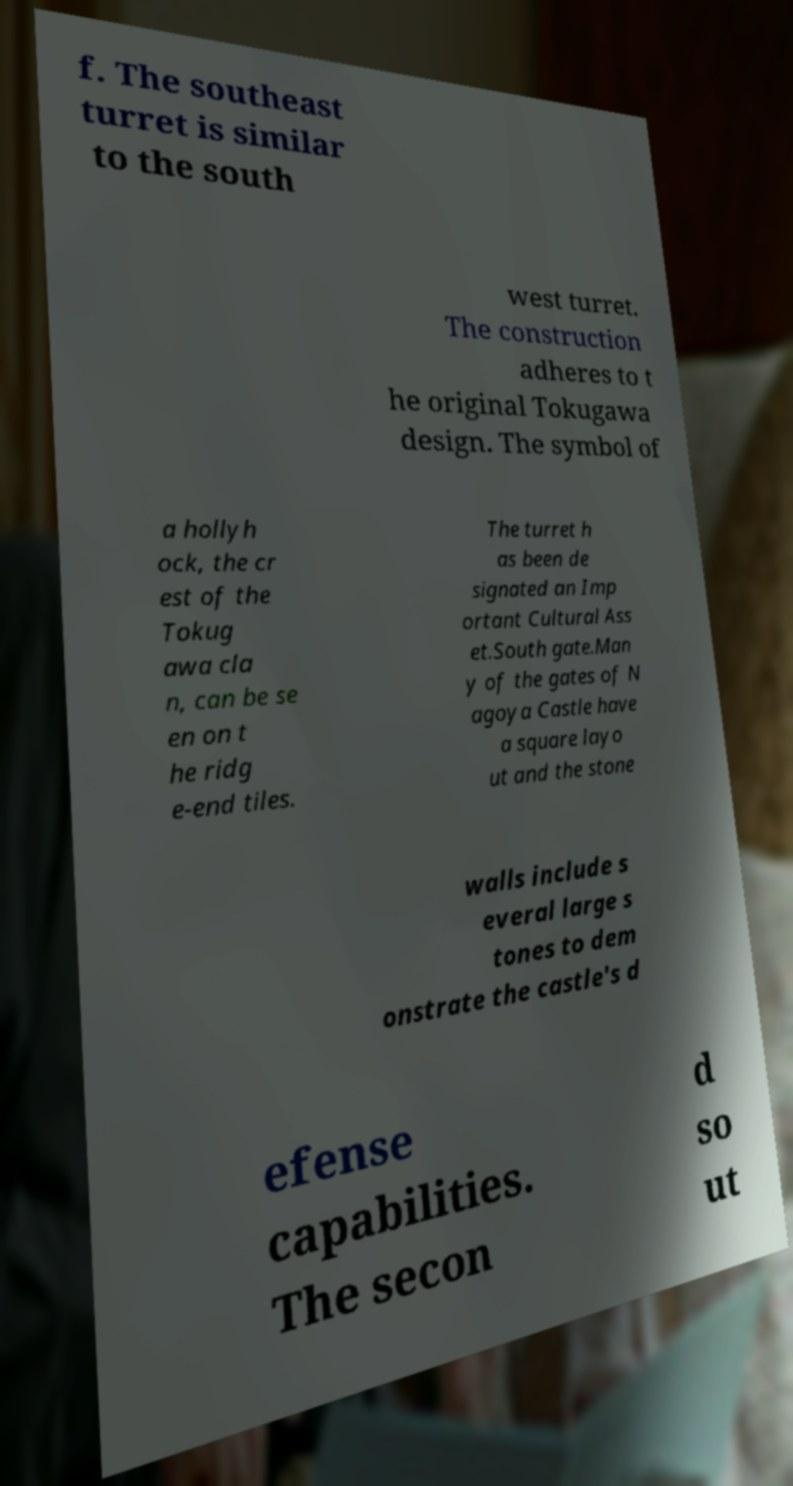Can you read and provide the text displayed in the image?This photo seems to have some interesting text. Can you extract and type it out for me? f. The southeast turret is similar to the south west turret. The construction adheres to t he original Tokugawa design. The symbol of a hollyh ock, the cr est of the Tokug awa cla n, can be se en on t he ridg e-end tiles. The turret h as been de signated an Imp ortant Cultural Ass et.South gate.Man y of the gates of N agoya Castle have a square layo ut and the stone walls include s everal large s tones to dem onstrate the castle's d efense capabilities. The secon d so ut 